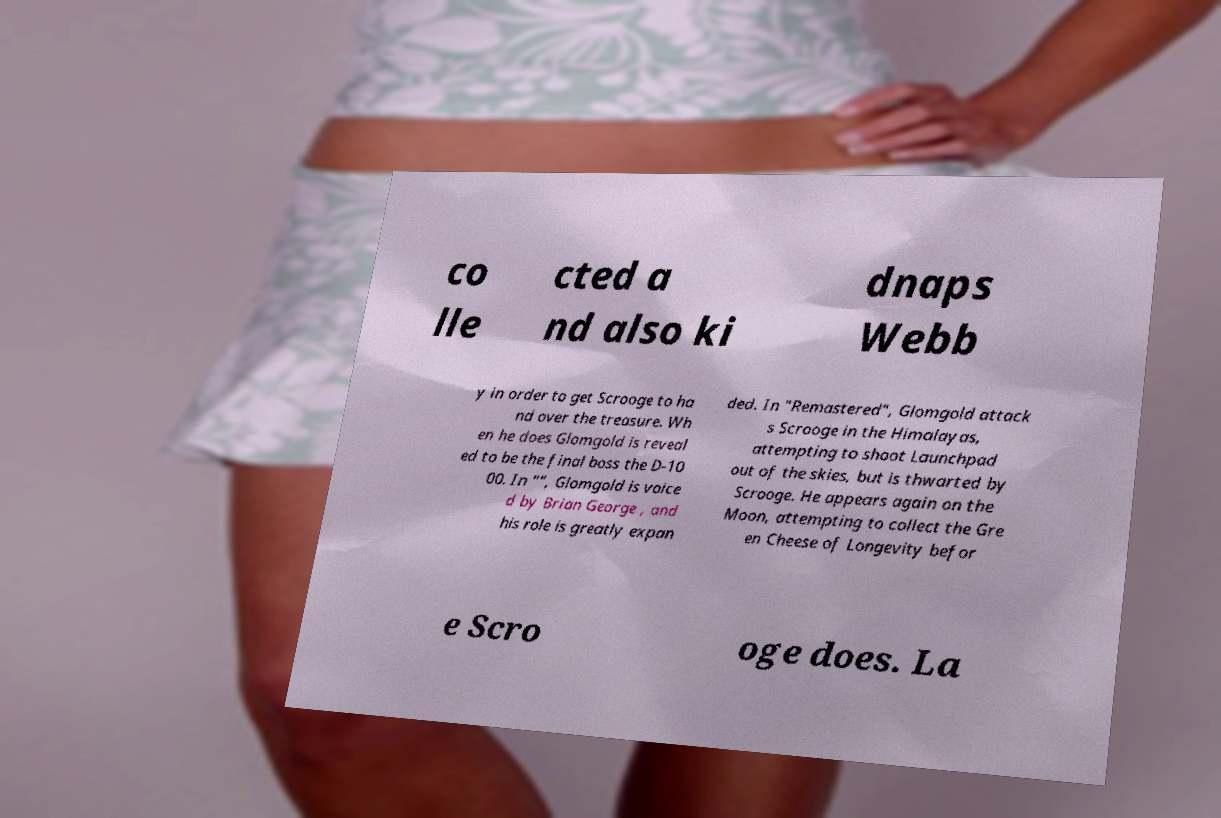Can you accurately transcribe the text from the provided image for me? co lle cted a nd also ki dnaps Webb y in order to get Scrooge to ha nd over the treasure. Wh en he does Glomgold is reveal ed to be the final boss the D-10 00. In "", Glomgold is voice d by Brian George , and his role is greatly expan ded. In "Remastered", Glomgold attack s Scrooge in the Himalayas, attempting to shoot Launchpad out of the skies, but is thwarted by Scrooge. He appears again on the Moon, attempting to collect the Gre en Cheese of Longevity befor e Scro oge does. La 